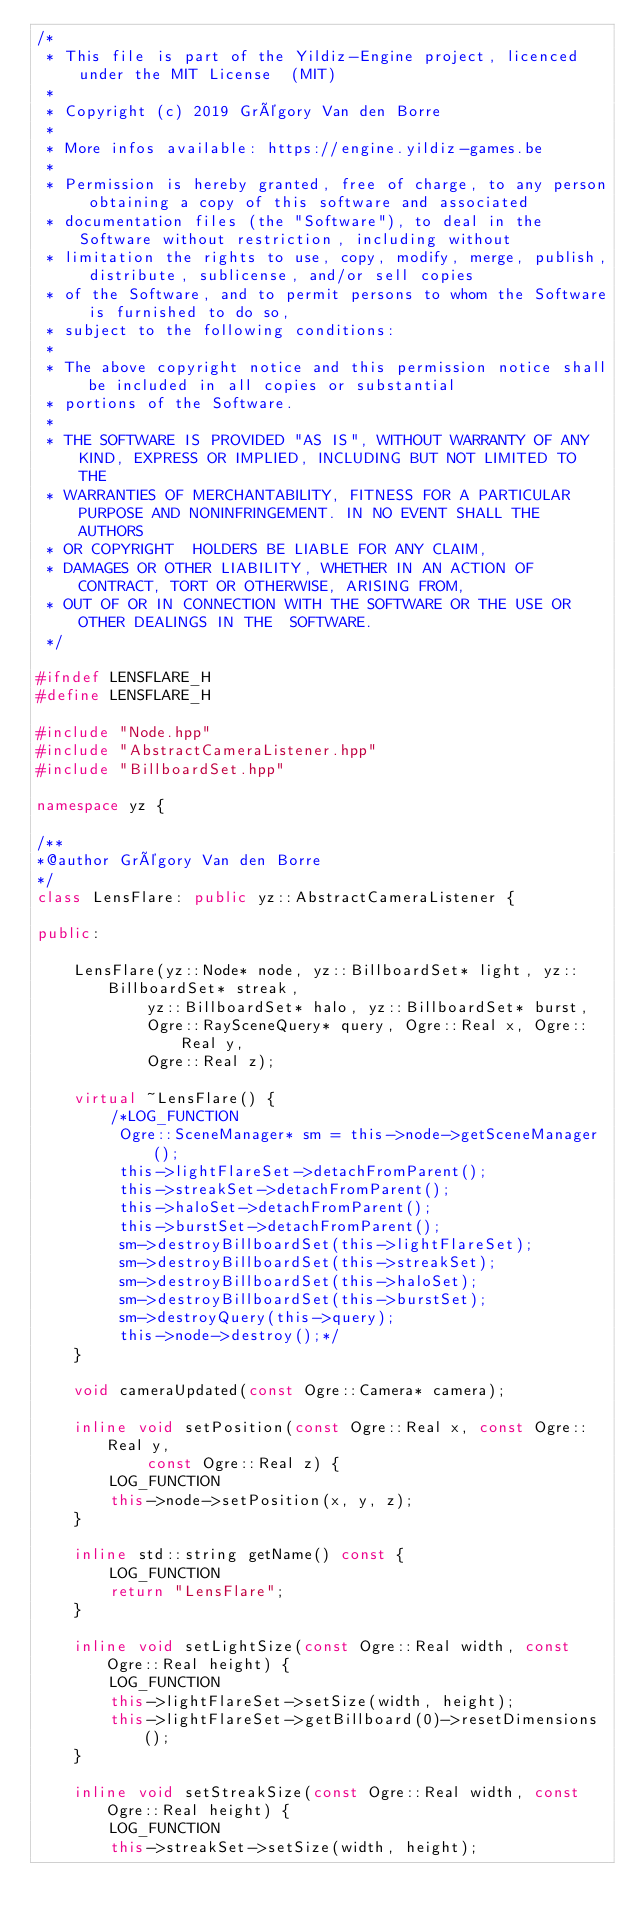<code> <loc_0><loc_0><loc_500><loc_500><_C++_>/*
 * This file is part of the Yildiz-Engine project, licenced under the MIT License  (MIT)
 *
 * Copyright (c) 2019 Grégory Van den Borre
 *
 * More infos available: https://engine.yildiz-games.be
 *
 * Permission is hereby granted, free of charge, to any person obtaining a copy of this software and associated
 * documentation files (the "Software"), to deal in the Software without restriction, including without
 * limitation the rights to use, copy, modify, merge, publish, distribute, sublicense, and/or sell copies
 * of the Software, and to permit persons to whom the Software is furnished to do so,
 * subject to the following conditions:
 *
 * The above copyright notice and this permission notice shall be included in all copies or substantial
 * portions of the Software.
 *
 * THE SOFTWARE IS PROVIDED "AS IS", WITHOUT WARRANTY OF ANY KIND, EXPRESS OR IMPLIED, INCLUDING BUT NOT LIMITED TO THE
 * WARRANTIES OF MERCHANTABILITY, FITNESS FOR A PARTICULAR PURPOSE AND NONINFRINGEMENT. IN NO EVENT SHALL THE AUTHORS
 * OR COPYRIGHT  HOLDERS BE LIABLE FOR ANY CLAIM,
 * DAMAGES OR OTHER LIABILITY, WHETHER IN AN ACTION OF CONTRACT, TORT OR OTHERWISE, ARISING FROM,
 * OUT OF OR IN CONNECTION WITH THE SOFTWARE OR THE USE OR OTHER DEALINGS IN THE  SOFTWARE.
 */

#ifndef LENSFLARE_H
#define LENSFLARE_H

#include "Node.hpp"
#include "AbstractCameraListener.hpp"
#include "BillboardSet.hpp"

namespace yz {

/**
*@author Grégory Van den Borre
*/
class LensFlare: public yz::AbstractCameraListener {

public:

	LensFlare(yz::Node* node, yz::BillboardSet* light, yz::BillboardSet* streak,
			yz::BillboardSet* halo, yz::BillboardSet* burst,
			Ogre::RaySceneQuery* query, Ogre::Real x, Ogre::Real y,
			Ogre::Real z);

	virtual ~LensFlare() {
		/*LOG_FUNCTION
		 Ogre::SceneManager* sm = this->node->getSceneManager();
		 this->lightFlareSet->detachFromParent();
		 this->streakSet->detachFromParent();
		 this->haloSet->detachFromParent();
		 this->burstSet->detachFromParent();
		 sm->destroyBillboardSet(this->lightFlareSet);
		 sm->destroyBillboardSet(this->streakSet);
		 sm->destroyBillboardSet(this->haloSet);
		 sm->destroyBillboardSet(this->burstSet);
		 sm->destroyQuery(this->query);
		 this->node->destroy();*/
	}

	void cameraUpdated(const Ogre::Camera* camera);

	inline void setPosition(const Ogre::Real x, const Ogre::Real y,
			const Ogre::Real z) {
	    LOG_FUNCTION
		this->node->setPosition(x, y, z);
	}

	inline std::string getName() const {
	    LOG_FUNCTION
		return "LensFlare";
	}

	inline void setLightSize(const Ogre::Real width, const Ogre::Real height) {
	    LOG_FUNCTION
		this->lightFlareSet->setSize(width, height);
		this->lightFlareSet->getBillboard(0)->resetDimensions();
	}

	inline void setStreakSize(const Ogre::Real width, const Ogre::Real height) {
	    LOG_FUNCTION
		this->streakSet->setSize(width, height);</code> 